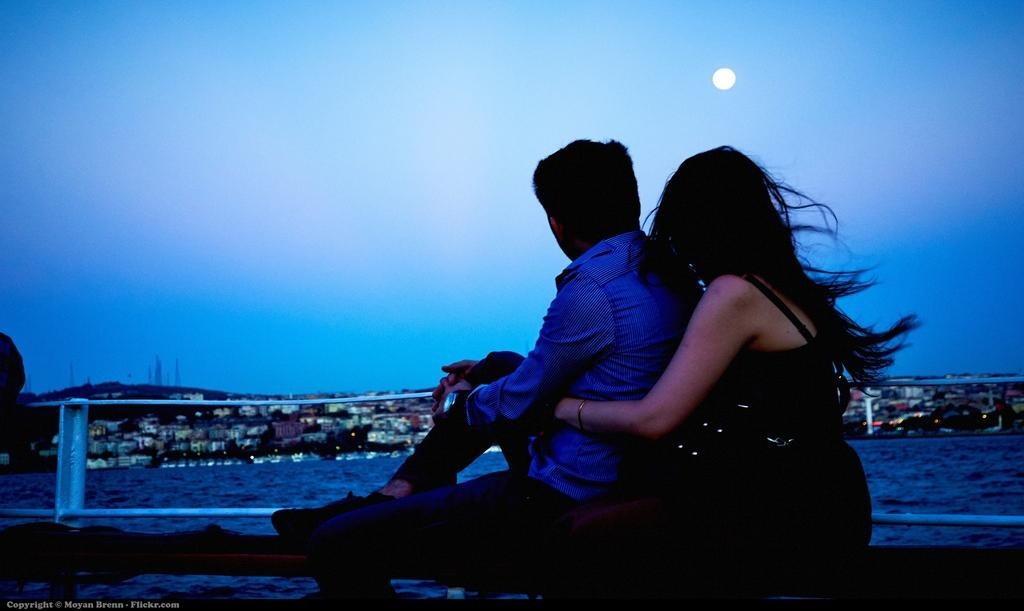What are the two people doing in the image? The two people are sitting on an object in the image. What can be seen in the background behind the people? There are houses in front of the people in the image. What celestial body is visible in the sky? The moon is visible in the sky in the image. Can you describe any additional features of the image? The image has a watermark. What type of brush is being used by the grandfather in the image? There is no grandfather or brush present in the image. What kind of flowers can be seen growing near the people in the image? There are no flowers visible in the image. 